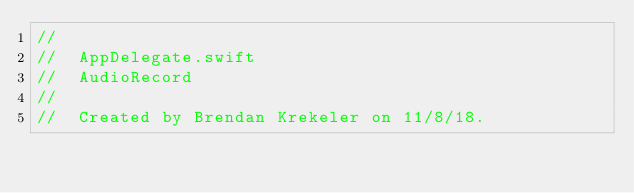<code> <loc_0><loc_0><loc_500><loc_500><_Swift_>//
//  AppDelegate.swift
//  AudioRecord
//
//  Created by Brendan Krekeler on 11/8/18.</code> 